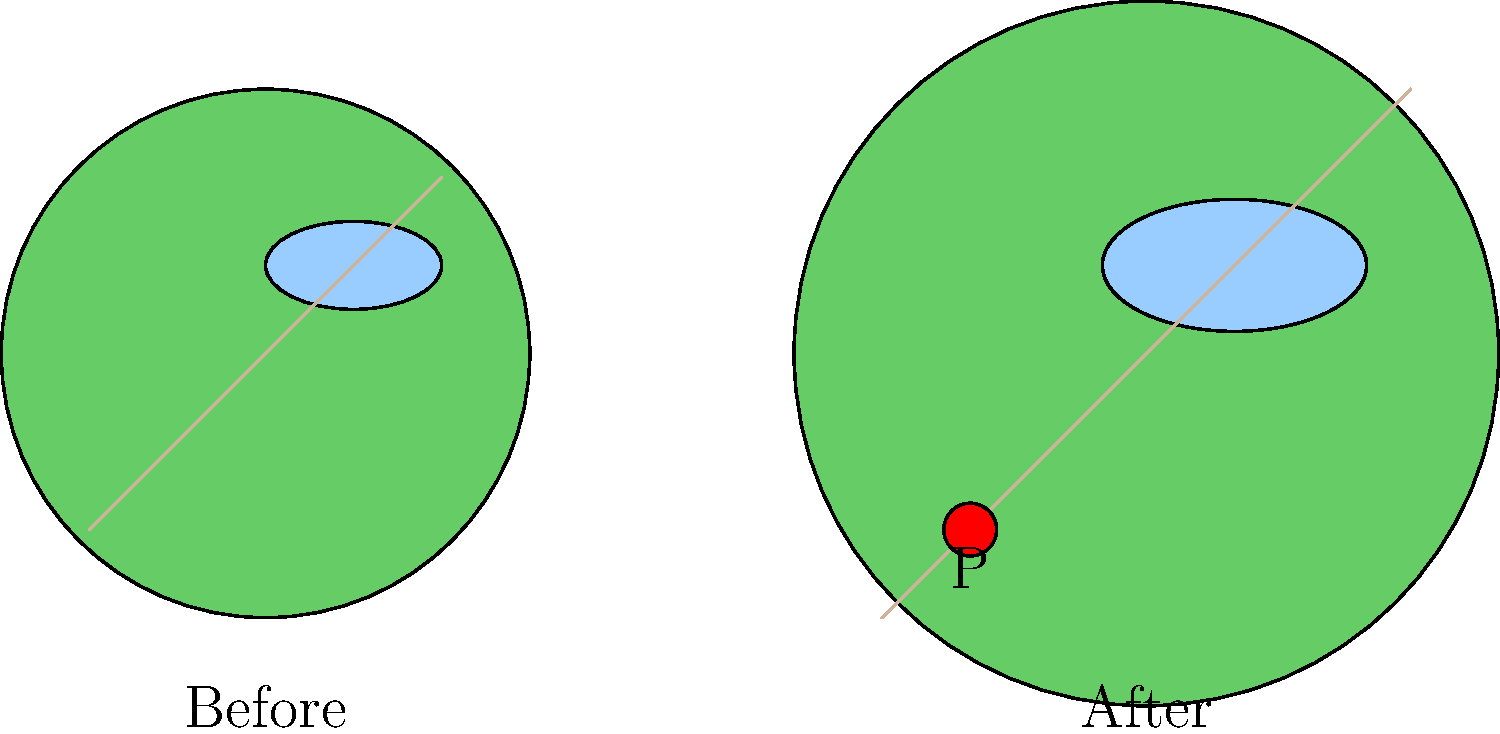The proposed town park expansion plan includes enlarging the existing park area and adding a new feature. Based on the before-and-after diagram, what is the most significant addition to the park, and where is it located? To answer this question, we need to carefully compare the "Before" and "After" diagrams of the proposed town park expansion plan:

1. Overall size: The park's circular boundary has increased in diameter, indicating an expansion of the total area.

2. Existing features:
   a. The central water feature (likely a pond) has been enlarged.
   b. The diagonal path across the park has been extended to match the new boundaries.

3. New feature: In the "After" diagram, we can see a new circular feature added to the lower-left quadrant of the park. This is the most significant addition, as it's the only completely new element in the expanded park.

4. Location: The new feature is marked with a red circle and labeled "P" in the lower-left corner of the expanded park area.

Given the context of a local resident interested in town developments, this new feature is likely a significant addition to the park, such as a playground, pavilion, or performance area.
Answer: A new feature (P) in the lower-left corner 